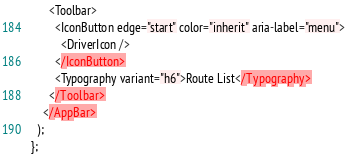<code> <loc_0><loc_0><loc_500><loc_500><_TypeScript_>      <Toolbar>
        <IconButton edge="start" color="inherit" aria-label="menu">
          <DriverIcon />
        </IconButton>
        <Typography variant="h6">Route List</Typography>
      </Toolbar>
    </AppBar>
  );
};
</code> 